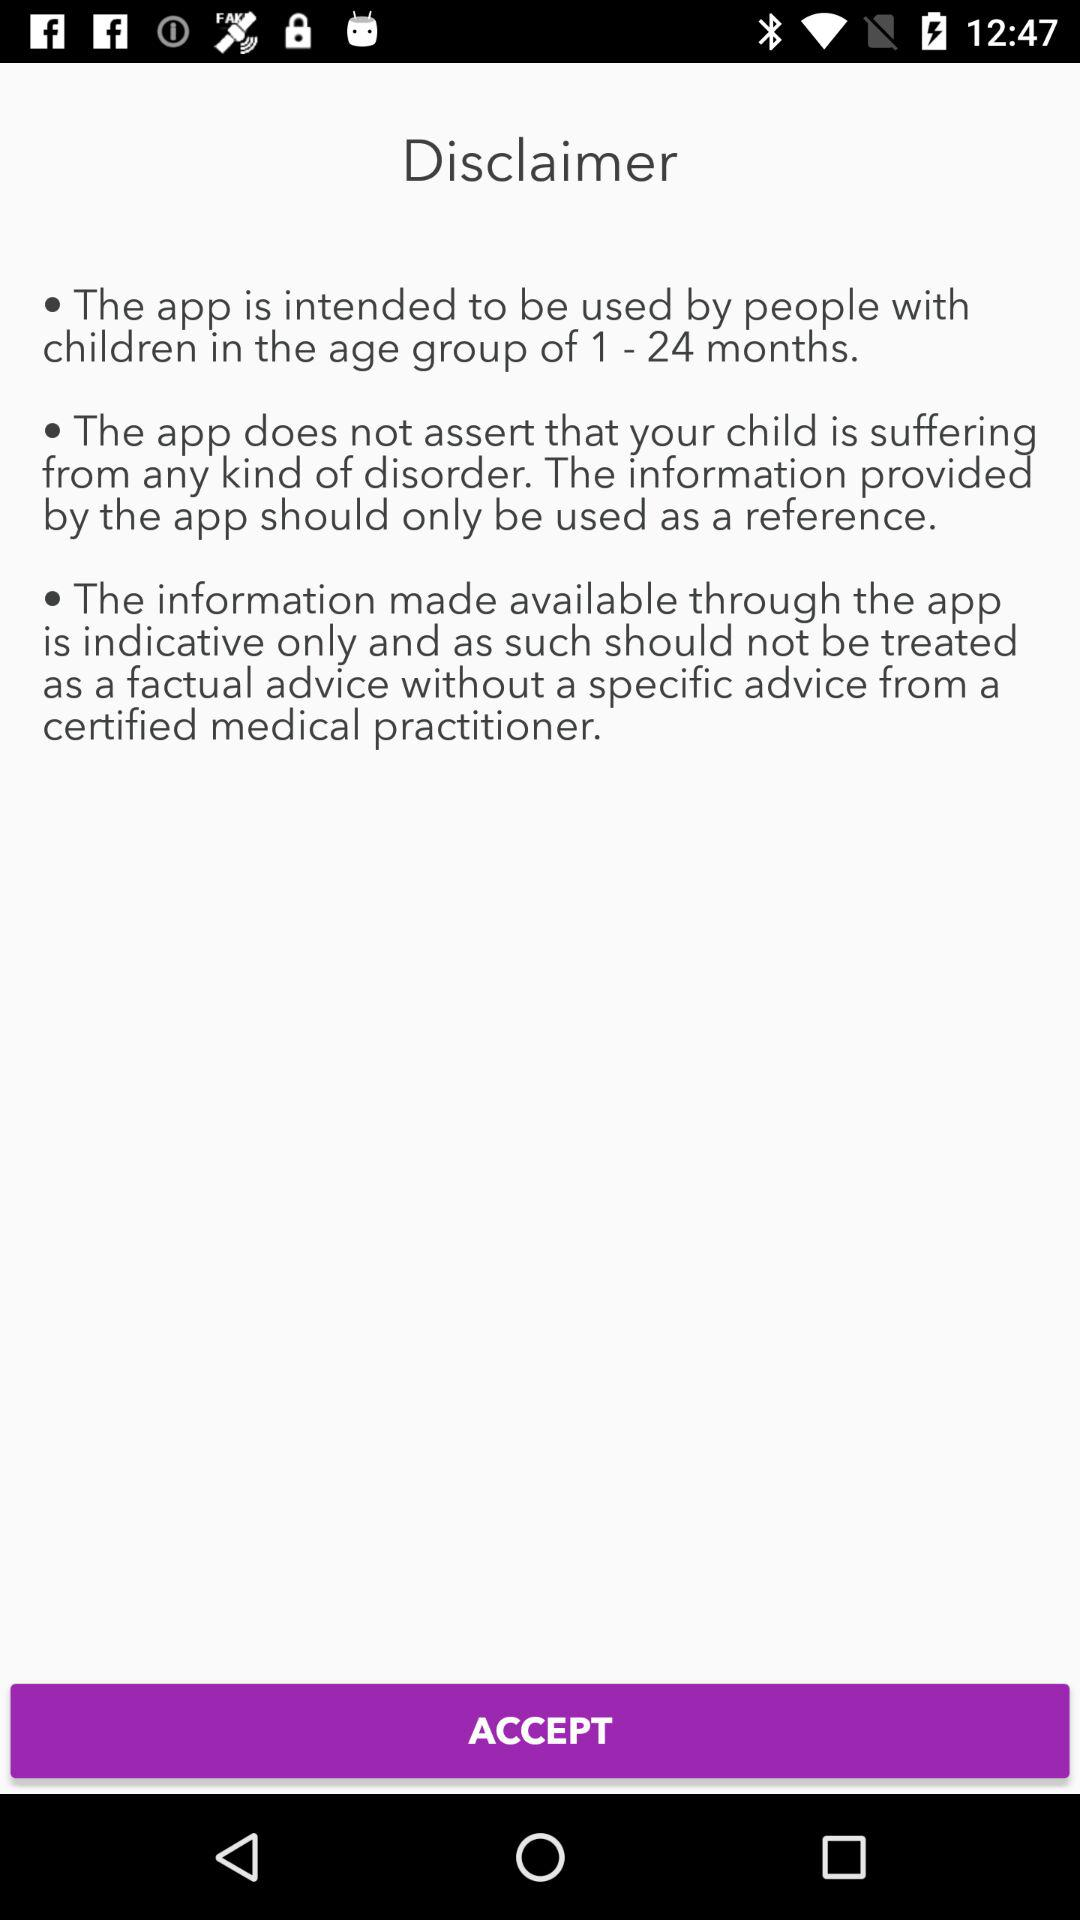How many disclaimers are on the screen?
Answer the question using a single word or phrase. 3 